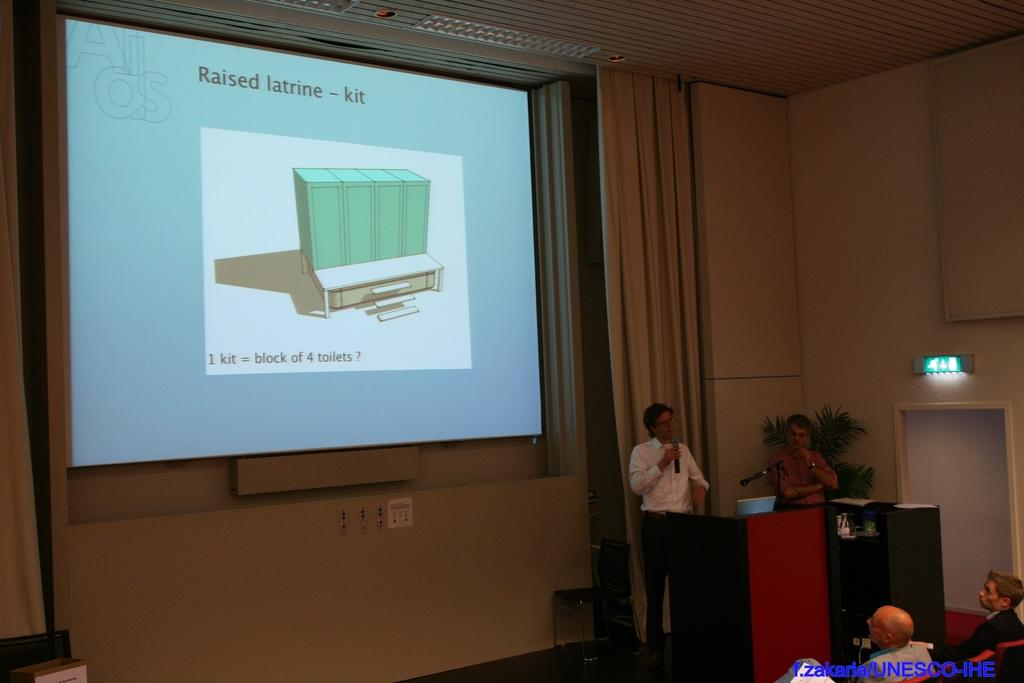<image>
Offer a succinct explanation of the picture presented. A man is talking about raised latrines in a lecture hall. 